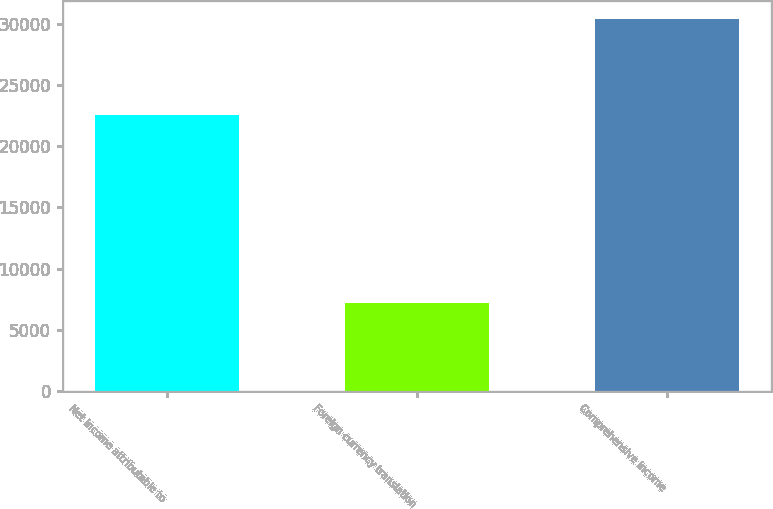Convert chart. <chart><loc_0><loc_0><loc_500><loc_500><bar_chart><fcel>Net income attributable to<fcel>Foreign currency translation<fcel>Comprehensive income<nl><fcel>22588<fcel>7217<fcel>30378<nl></chart> 